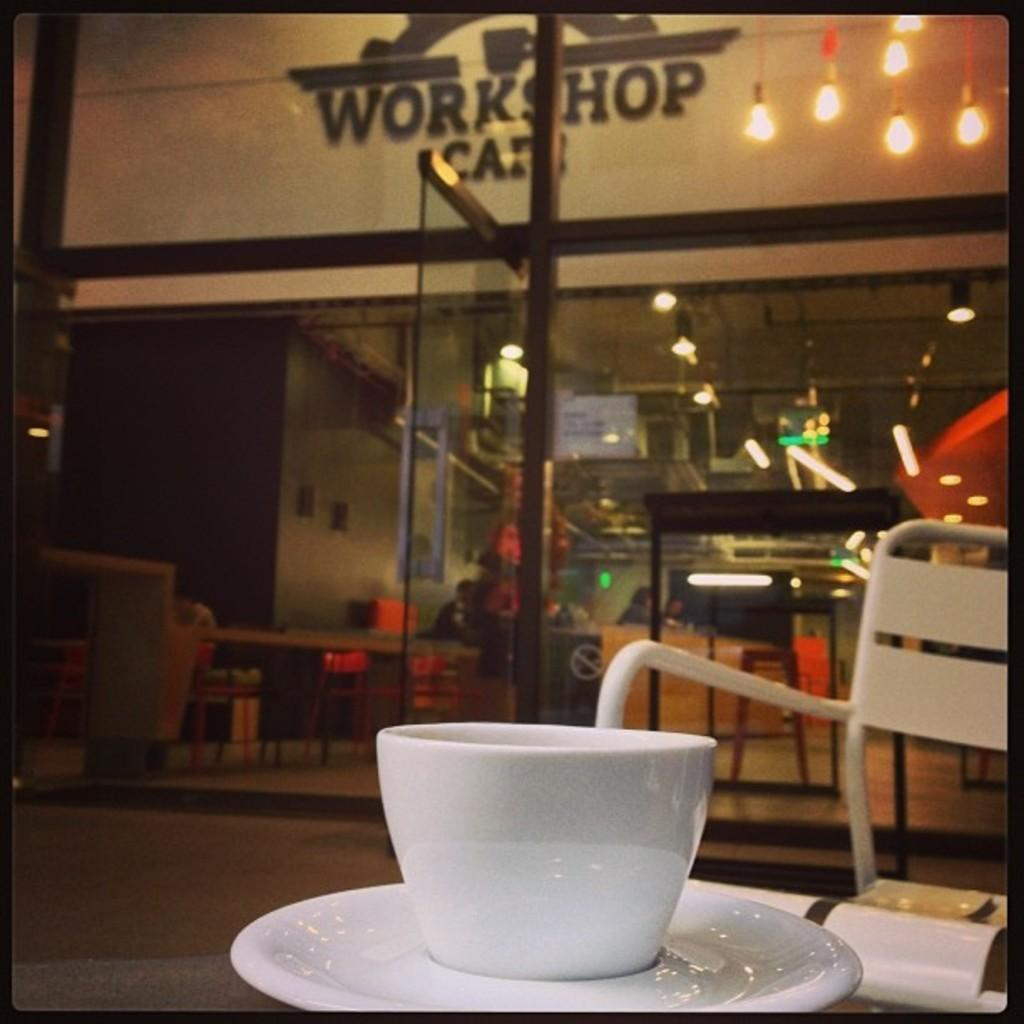Provide a one-sentence caption for the provided image. a white cup next to a store that says workshop. 